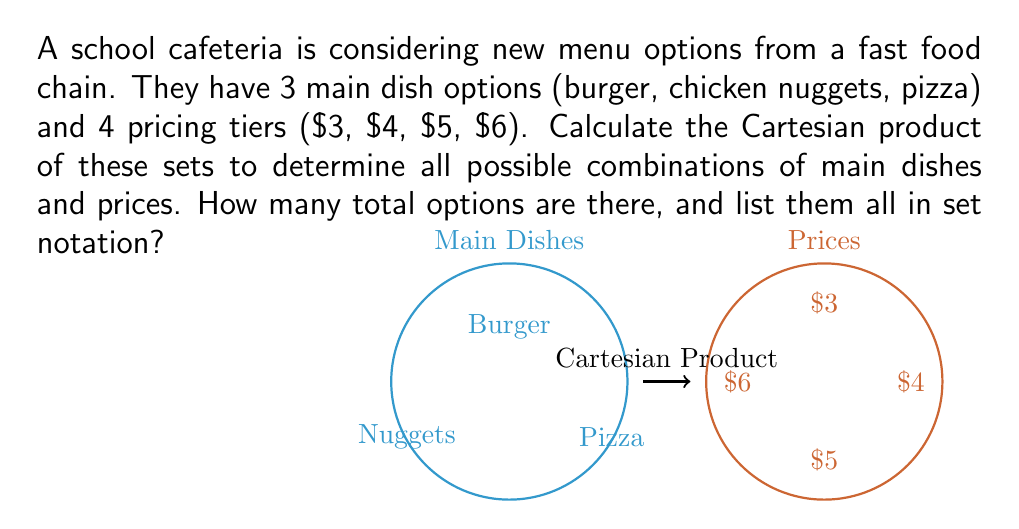Provide a solution to this math problem. To solve this problem, we need to understand the concept of Cartesian product and apply it to our sets.

1) Let's define our sets:
   $M = \{burger, chicken nuggets, pizza\}$ (Main dishes)
   $P = \{3, 4, 5, 6\}$ (Prices in dollars)

2) The Cartesian product $M \times P$ is the set of all ordered pairs $(m,p)$ where $m \in M$ and $p \in P$.

3) To calculate the number of elements in the Cartesian product, we multiply the number of elements in each set:
   $|M \times P| = |M| \times |P| = 3 \times 4 = 12$

4) To list all elements, we pair each element from $M$ with each element from $P$:

   $M \times P = \{$ 
   $(burger, 3), (burger, 4), (burger, 5), (burger, 6),$
   $(chicken nuggets, 3), (chicken nuggets, 4), (chicken nuggets, 5), (chicken nuggets, 6),$
   $(pizza, 3), (pizza, 4), (pizza, 5), (pizza, 6)$ 
   $\}$

5) In set notation, we typically use parentheses for ordered pairs and curly braces for sets.

Therefore, there are 12 total options, and they can be represented in set notation as shown above.
Answer: 12; $\{(burger, 3), (burger, 4), (burger, 5), (burger, 6), (chicken nuggets, 3), (chicken nuggets, 4), (chicken nuggets, 5), (chicken nuggets, 6), (pizza, 3), (pizza, 4), (pizza, 5), (pizza, 6)\}$ 